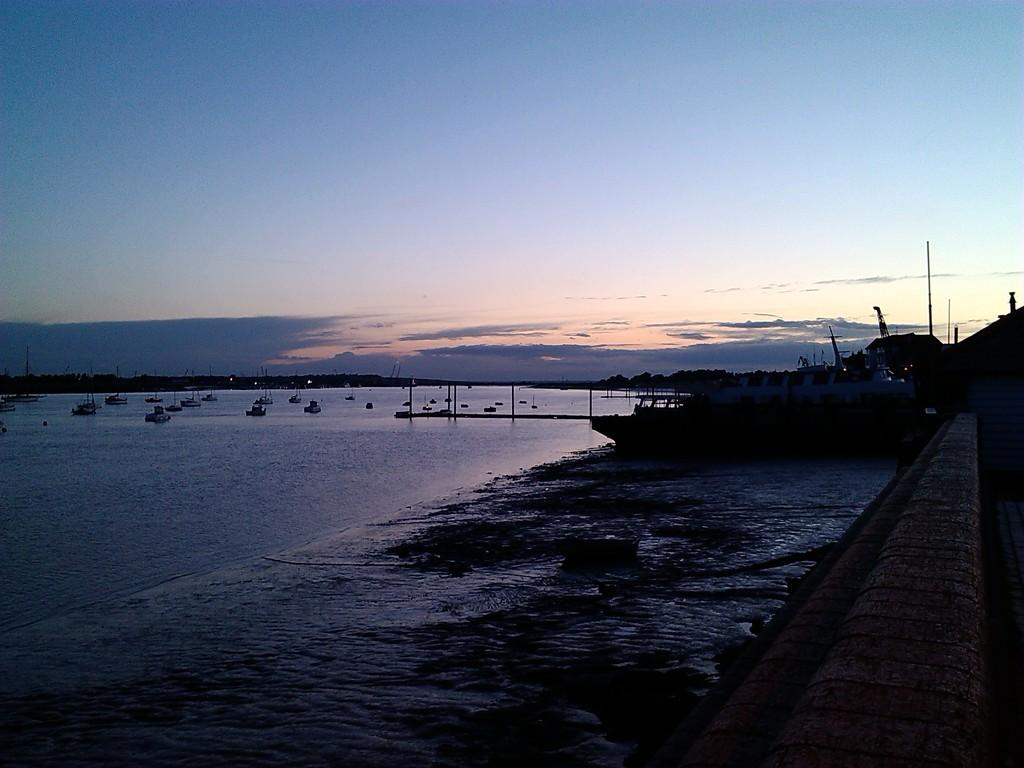What is the main element in the image? There is water in the image. What is on the water in the image? There are boats on the water. What can be seen on the right side of the image? There is a road on the right side of the image. What is visible in the background of the image? Hills and the sky are visible in the background of the image. What structures are present in the image? There are poles in the image. What type of produce is being harvested in the image? There is no produce being harvested in the image; it features water, boats, a road, hills, the sky, and poles. How many pigs can be seen running along the road in the image? There are no pigs present in the image. 